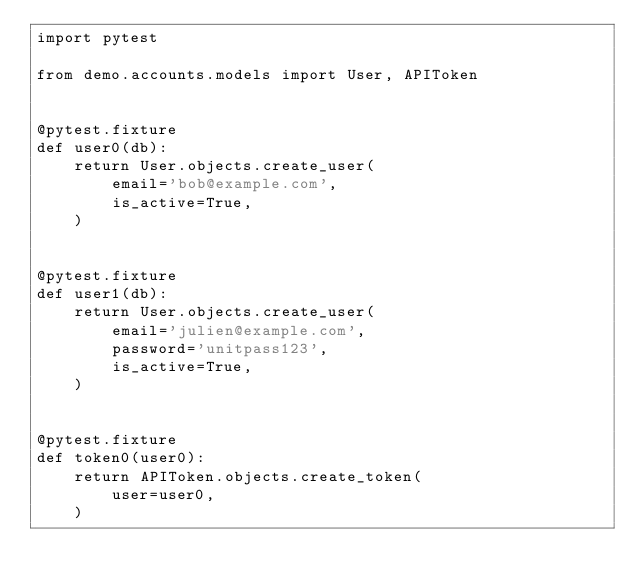<code> <loc_0><loc_0><loc_500><loc_500><_Python_>import pytest

from demo.accounts.models import User, APIToken


@pytest.fixture
def user0(db):
    return User.objects.create_user(
        email='bob@example.com',
        is_active=True,
    )


@pytest.fixture
def user1(db):
    return User.objects.create_user(
        email='julien@example.com',
        password='unitpass123',
        is_active=True,
    )


@pytest.fixture
def token0(user0):
    return APIToken.objects.create_token(
        user=user0,
    )
</code> 